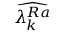Convert formula to latex. <formula><loc_0><loc_0><loc_500><loc_500>\widehat { \lambda _ { k } ^ { R a } }</formula> 